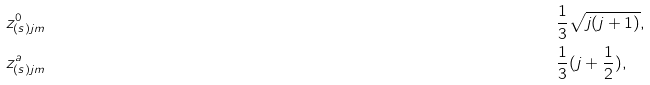<formula> <loc_0><loc_0><loc_500><loc_500>& z ^ { 0 } _ { ( s ) j m } & & \frac { 1 } { 3 } \sqrt { j ( j + 1 ) } , \\ & z ^ { a } _ { ( s ) j m } & & \frac { 1 } { 3 } ( j + \frac { 1 } { 2 } ) ,</formula> 